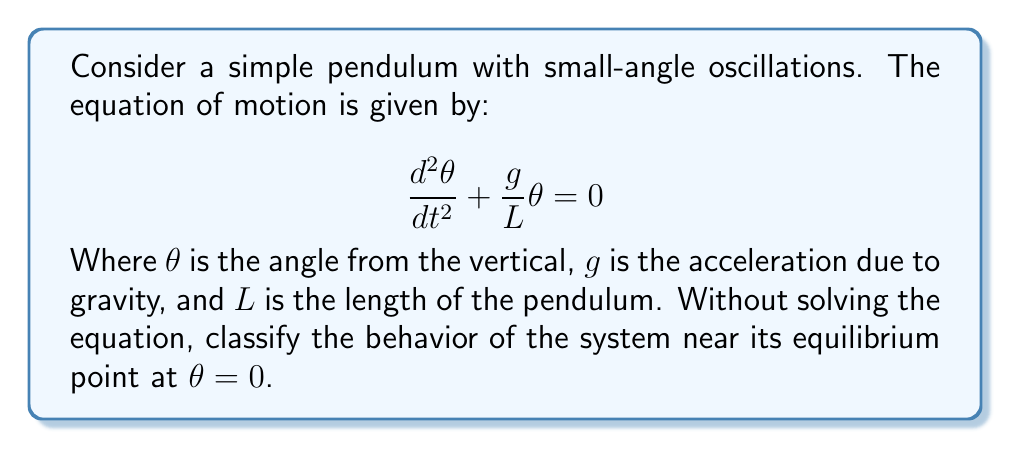Teach me how to tackle this problem. Let's approach this step-by-step:

1) First, we need to recognize that this is a second-order linear differential equation.

2) To classify the behavior, we need to compare it to the standard form of a second-order linear differential equation:

   $$ \frac{d^2x}{dt^2} + 2\zeta\omega_n\frac{dx}{dt} + \omega_n^2x = 0 $$

   Where $\zeta$ is the damping ratio and $\omega_n$ is the natural frequency.

3) Comparing our equation to the standard form, we can see that:
   - There is no damping term ($\frac{dx}{dt}$), so $\zeta = 0$
   - $\omega_n^2 = \frac{g}{L}$

4) When $\zeta = 0$, the system is undamped.

5) For an undamped system, the behavior is determined by the natural frequency $\omega_n$:
   - If $\omega_n$ is real (which it is in this case, as $\frac{g}{L}$ is always positive), the system will exhibit simple harmonic motion.

6) Simple harmonic motion means the pendulum will oscillate back and forth indefinitely with constant amplitude and frequency.

7) The equilibrium point at $\theta = 0$ (vertical position) is therefore classified as a center.
Answer: Center (simple harmonic motion) 